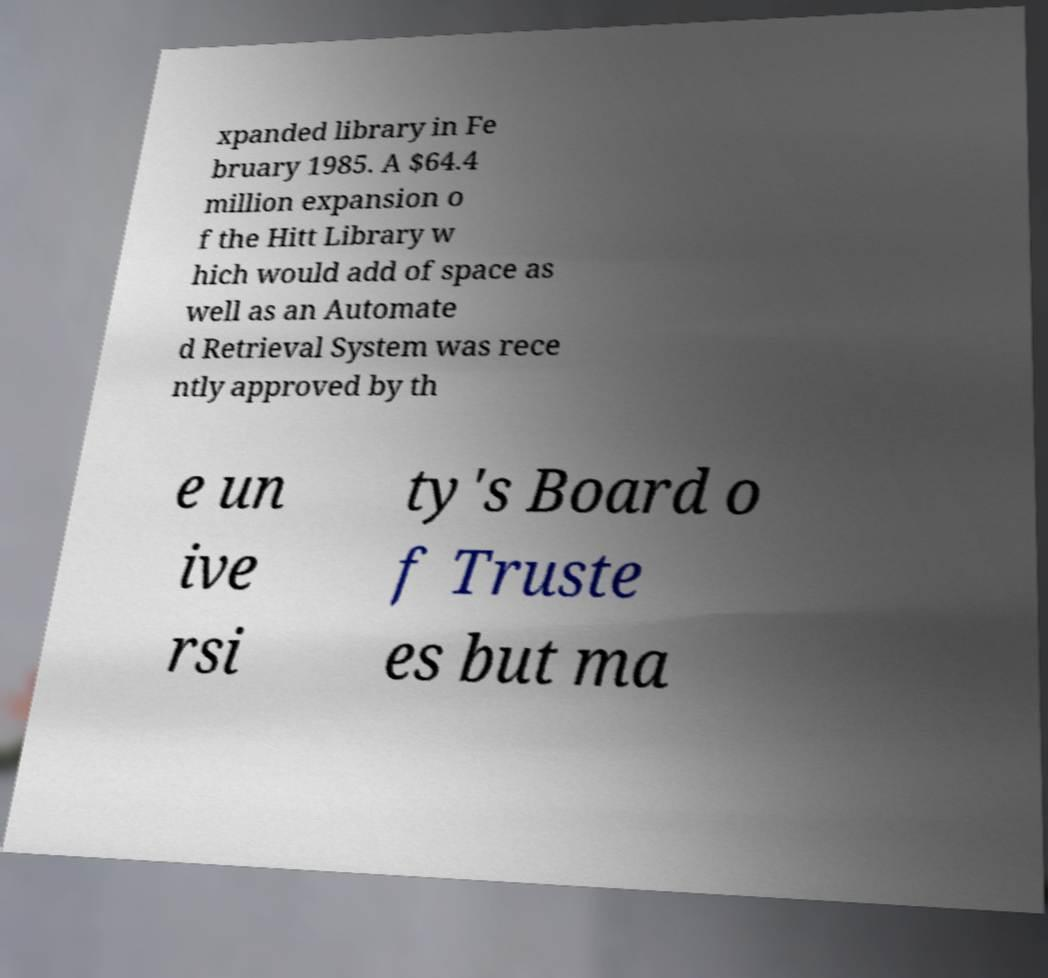Please identify and transcribe the text found in this image. xpanded library in Fe bruary 1985. A $64.4 million expansion o f the Hitt Library w hich would add of space as well as an Automate d Retrieval System was rece ntly approved by th e un ive rsi ty's Board o f Truste es but ma 